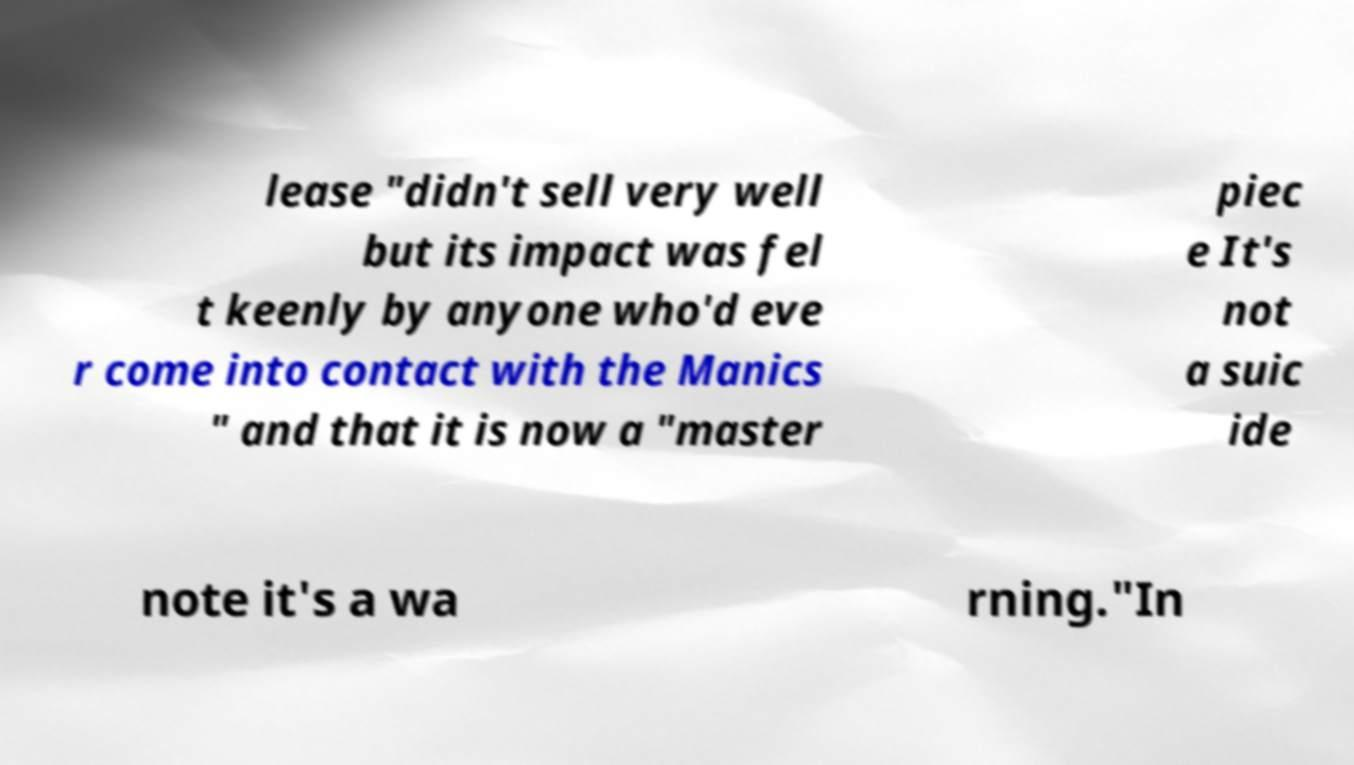I need the written content from this picture converted into text. Can you do that? lease "didn't sell very well but its impact was fel t keenly by anyone who'd eve r come into contact with the Manics " and that it is now a "master piec e It's not a suic ide note it's a wa rning."In 